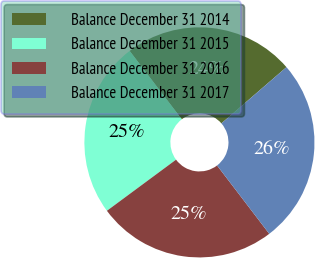<chart> <loc_0><loc_0><loc_500><loc_500><pie_chart><fcel>Balance December 31 2014<fcel>Balance December 31 2015<fcel>Balance December 31 2016<fcel>Balance December 31 2017<nl><fcel>24.03%<fcel>24.76%<fcel>25.25%<fcel>25.96%<nl></chart> 